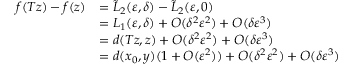<formula> <loc_0><loc_0><loc_500><loc_500>\begin{array} { r l } { f ( T z ) - f ( z ) } & { = \tilde { L } _ { 2 } ( \varepsilon , \delta ) - \tilde { L } _ { 2 } ( \varepsilon , 0 ) } \\ & { = L _ { 1 } ( \varepsilon , \delta ) + O ( \delta ^ { 2 } \varepsilon ^ { 2 } ) + O ( \delta \varepsilon ^ { 3 } ) } \\ & { = d ( T z , z ) + O ( \delta ^ { 2 } \varepsilon ^ { 2 } ) + O ( \delta \varepsilon ^ { 3 } ) } \\ & { = d ( x _ { 0 } , y ) ( 1 + O ( \varepsilon ^ { 2 } ) ) + O ( \delta ^ { 2 } \varepsilon ^ { 2 } ) + O ( \delta \varepsilon ^ { 3 } ) } \end{array}</formula> 